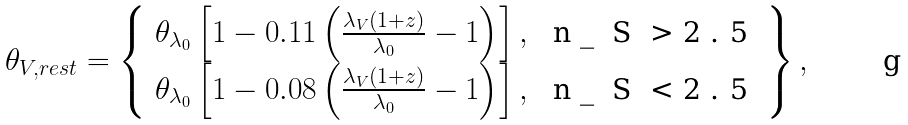Convert formula to latex. <formula><loc_0><loc_0><loc_500><loc_500>\theta _ { V , r e s t } = \left \{ \begin{array} { l l } \theta _ { \lambda _ { 0 } } \left [ 1 - 0 . 1 1 \left ( \frac { \lambda _ { V } ( 1 + z ) } { \lambda _ { 0 } } - 1 \right ) \right ] , & $ n _ { S } > 2 . 5 $ \\ \theta _ { \lambda _ { 0 } } \left [ 1 - 0 . 0 8 \left ( \frac { \lambda _ { V } ( 1 + z ) } { \lambda _ { 0 } } - 1 \right ) \right ] , & $ n _ { S } < 2 . 5 $ \end{array} \right \} ,</formula> 